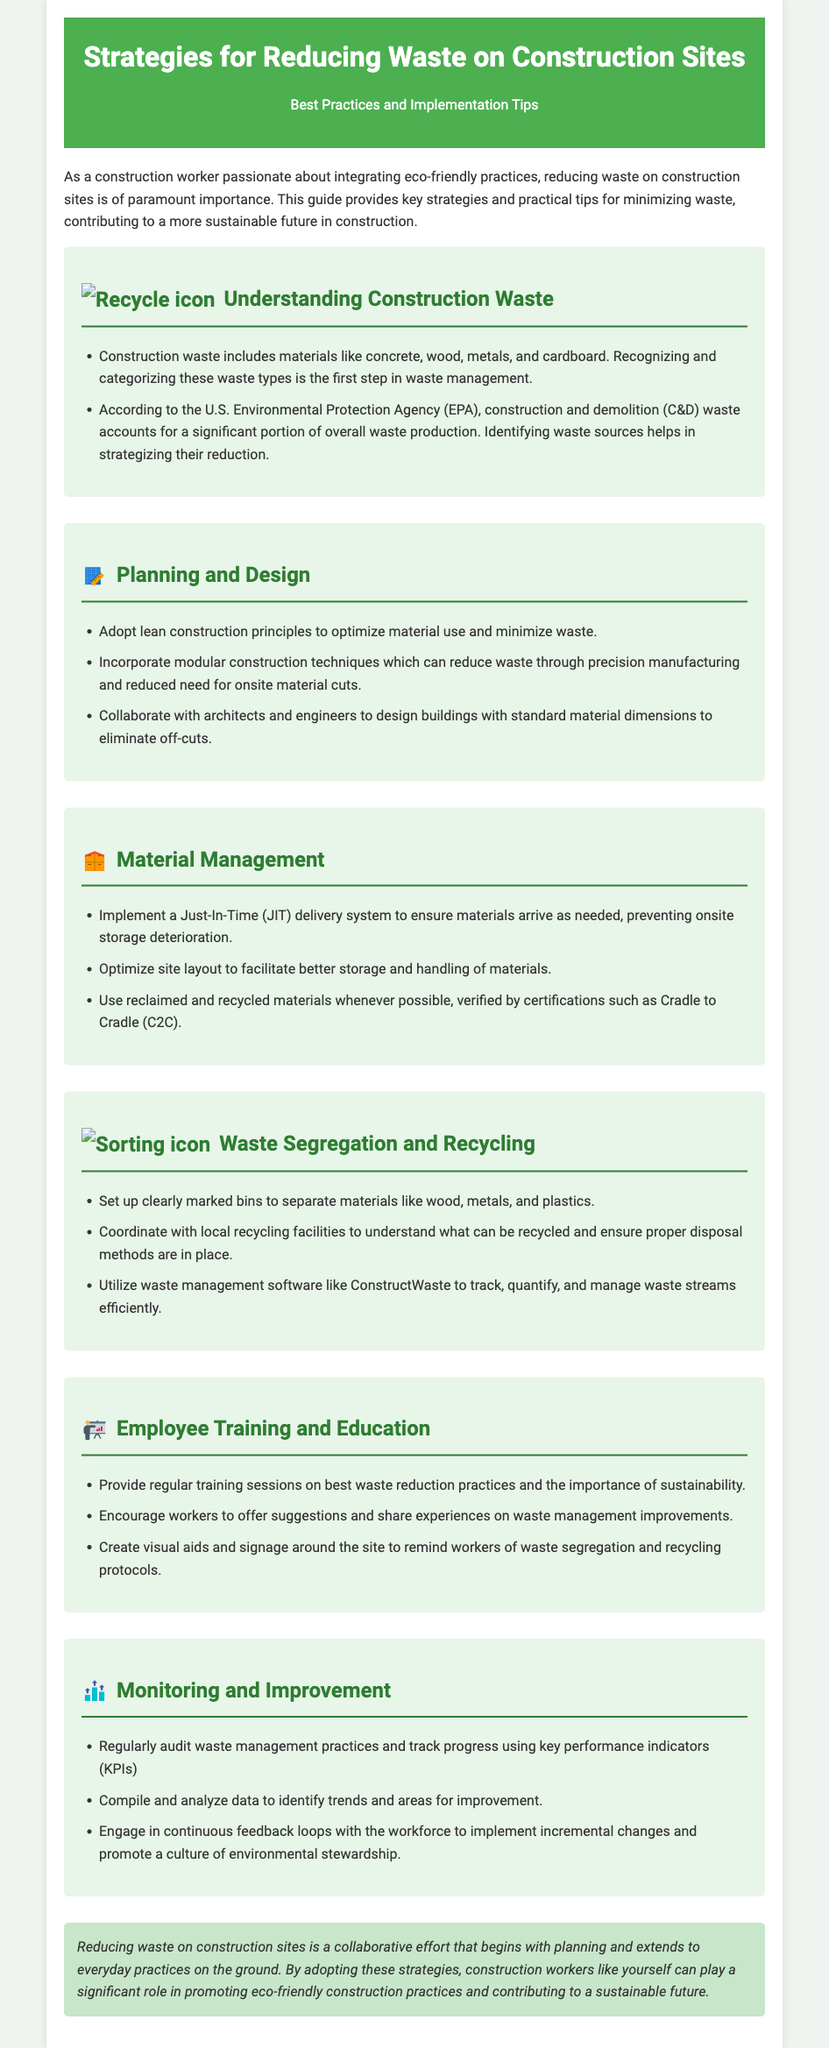What is the title of the guide? The title of the guide is mentioned at the top of the document in a prominent font.
Answer: Strategies for Reducing Waste on Construction Sites What type of waste is primarily addressed in this guide? The types of waste discussed are specified in the 'Understanding Construction Waste' section.
Answer: Construction and demolition (C&D) waste What is one method to optimize material use mentioned in the guide? The guide lists strategies in the 'Planning and Design' section, and one method is highlighted there.
Answer: Lean construction principles What should be coordinated with local recycling facilities? The document advises specific actions in the 'Waste Segregation and Recycling' section regarding local recycling facilities.
Answer: Recycling practices What type of system is recommended for material delivery? This is mentioned in the 'Material Management' section as a way to handle delivery efficiently.
Answer: Just-In-Time (JIT) delivery system What is a key element of employee training according to the guide? The guide emphasizes the importance of certain elements in the 'Employee Training and Education' section.
Answer: Best waste reduction practices How can waste management progress be tracked? The 'Monitoring and Improvement' section suggests a method for tracking waste management.
Answer: Key performance indicators (KPIs) What is the main goal of reducing waste on construction sites? The conclusion summarizes the overarching aim of the strategies presented in the guide.
Answer: Promoting eco-friendly construction practices 